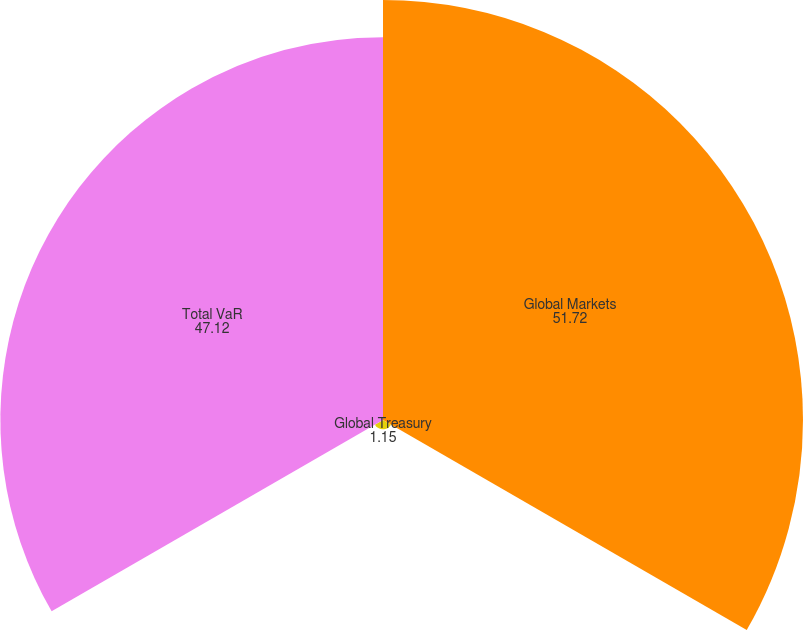Convert chart. <chart><loc_0><loc_0><loc_500><loc_500><pie_chart><fcel>Global Markets<fcel>Global Treasury<fcel>Total VaR<nl><fcel>51.72%<fcel>1.15%<fcel>47.12%<nl></chart> 